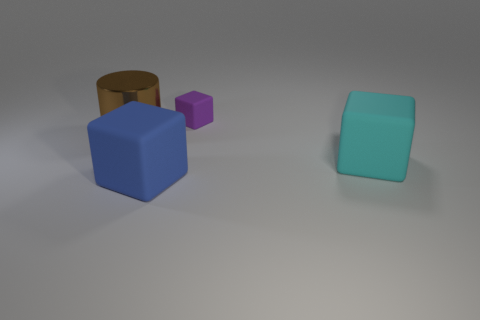Add 1 big green matte cubes. How many objects exist? 5 Subtract all blocks. How many objects are left? 1 Add 1 tiny brown matte cylinders. How many tiny brown matte cylinders exist? 1 Subtract 0 red cubes. How many objects are left? 4 Subtract all small rubber blocks. Subtract all metal objects. How many objects are left? 2 Add 4 large cyan things. How many large cyan things are left? 5 